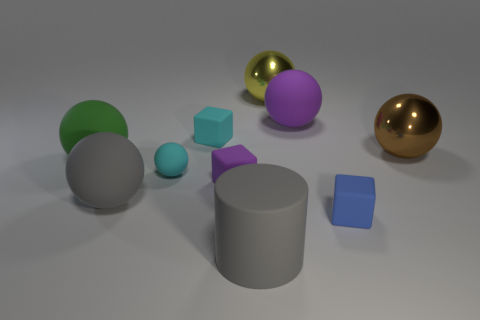There is a matte object that is both right of the cyan cube and behind the brown metallic ball; what is its color?
Provide a short and direct response. Purple. Does the blue rubber cube have the same size as the gray matte thing that is behind the rubber cylinder?
Give a very brief answer. No. What shape is the big gray object to the right of the small cyan matte ball?
Give a very brief answer. Cylinder. Is there anything else that is made of the same material as the big purple thing?
Keep it short and to the point. Yes. Are there more cyan rubber blocks that are to the right of the small blue matte object than big yellow matte blocks?
Offer a very short reply. No. There is a metallic object in front of the rubber sphere that is to the right of the large yellow shiny sphere; how many small cyan rubber things are in front of it?
Ensure brevity in your answer.  1. There is a purple object left of the large gray cylinder; is it the same size as the gray object behind the rubber cylinder?
Offer a very short reply. No. What is the gray thing behind the large matte thing in front of the blue thing made of?
Offer a very short reply. Rubber. What number of objects are objects that are in front of the yellow shiny ball or cyan rubber objects?
Your answer should be compact. 9. Are there an equal number of large gray things that are behind the cyan matte ball and brown balls that are right of the tiny purple matte thing?
Offer a very short reply. No. 